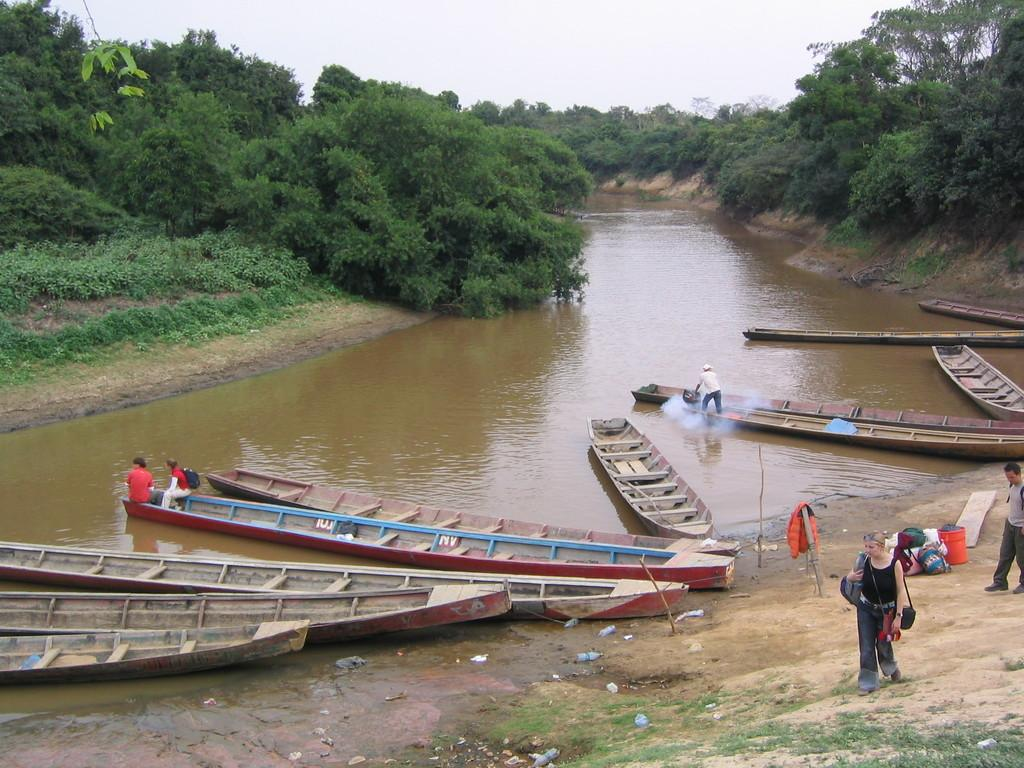What type of vehicles are in the water in the image? There are boats in the water in the image. What are the people on the boats doing? Some people are sitting on the boats. What can be seen in the background of the image? There are trees visible in the image. Can you see a snake slithering on the boats in the image? There is no snake present in the image; it only features boats in the water with people sitting on them. 